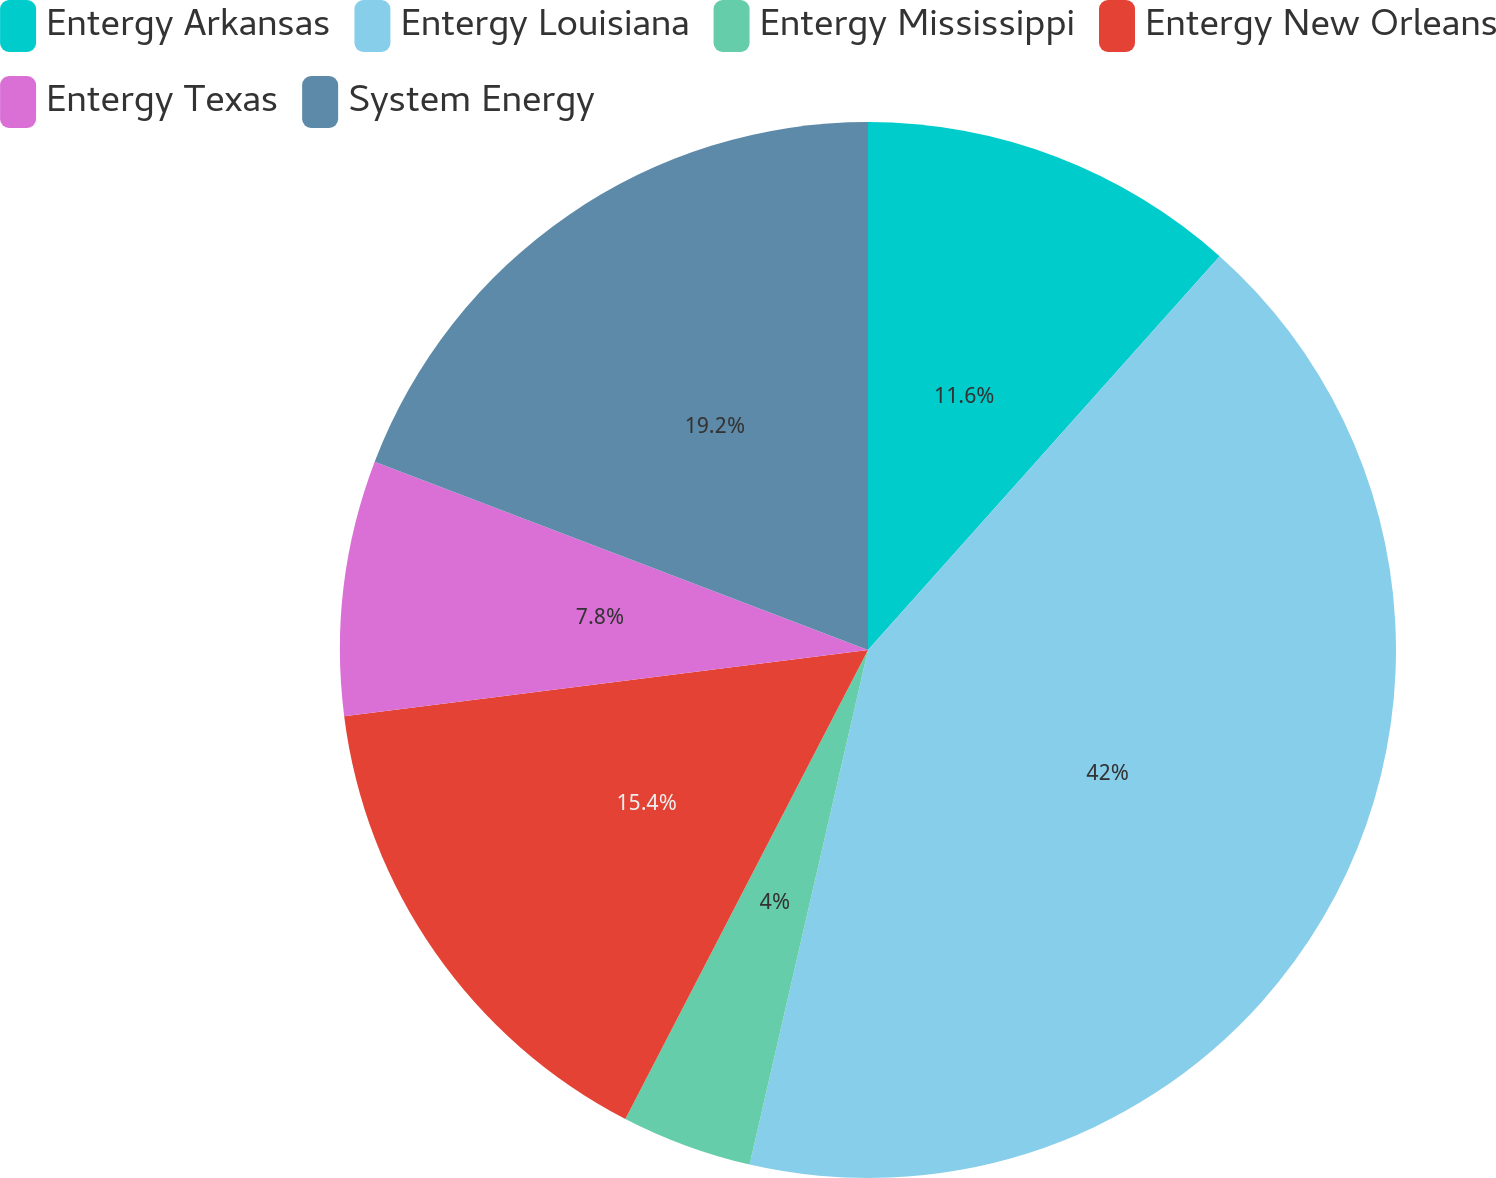Convert chart. <chart><loc_0><loc_0><loc_500><loc_500><pie_chart><fcel>Entergy Arkansas<fcel>Entergy Louisiana<fcel>Entergy Mississippi<fcel>Entergy New Orleans<fcel>Entergy Texas<fcel>System Energy<nl><fcel>11.6%<fcel>42.0%<fcel>4.0%<fcel>15.4%<fcel>7.8%<fcel>19.2%<nl></chart> 